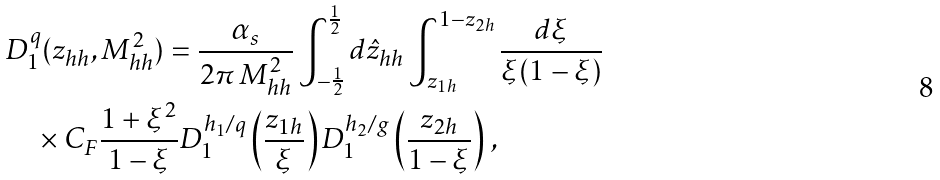Convert formula to latex. <formula><loc_0><loc_0><loc_500><loc_500>& D _ { 1 } ^ { q } ( z _ { h h } , M _ { h h } ^ { 2 } ) = \frac { \alpha _ { s } } { 2 \pi \, M _ { h h } ^ { 2 } } \int _ { - \frac { 1 } { 2 } } ^ { \frac { 1 } { 2 } } d \hat { z } _ { h h } \int _ { z _ { 1 h } } ^ { 1 - z _ { 2 h } } \frac { d \xi } { \xi ( 1 - \xi ) } \\ & \quad \times C _ { F } \frac { 1 + \xi ^ { 2 } } { 1 - \xi } D _ { 1 } ^ { h _ { 1 } / q } \left ( \frac { z _ { 1 h } } { \xi } \right ) D _ { 1 } ^ { h _ { 2 } / g } \left ( \frac { z _ { 2 h } } { 1 - \xi } \right ) \, ,</formula> 